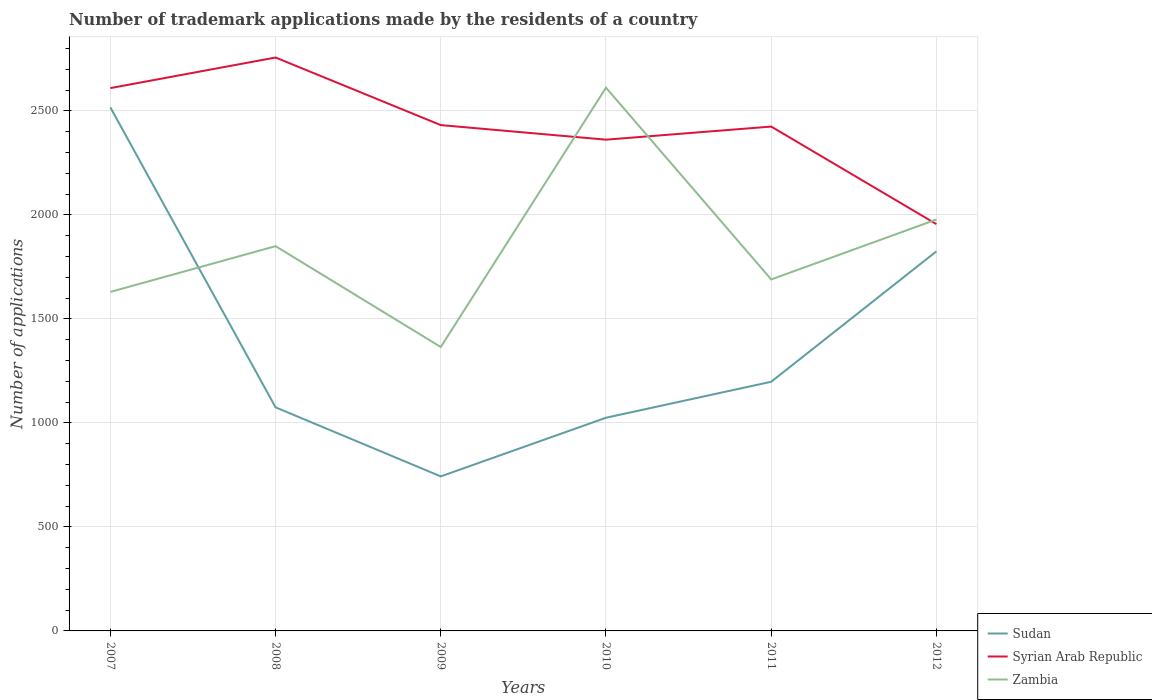How many different coloured lines are there?
Offer a terse response. 3. Is the number of lines equal to the number of legend labels?
Provide a succinct answer. Yes. Across all years, what is the maximum number of trademark applications made by the residents in Sudan?
Provide a succinct answer. 743. What is the total number of trademark applications made by the residents in Syrian Arab Republic in the graph?
Provide a succinct answer. 476. What is the difference between the highest and the second highest number of trademark applications made by the residents in Syrian Arab Republic?
Make the answer very short. 801. What is the difference between the highest and the lowest number of trademark applications made by the residents in Sudan?
Your response must be concise. 2. How many lines are there?
Your response must be concise. 3. How many years are there in the graph?
Ensure brevity in your answer.  6. What is the difference between two consecutive major ticks on the Y-axis?
Give a very brief answer. 500. Does the graph contain grids?
Your answer should be very brief. Yes. Where does the legend appear in the graph?
Your answer should be compact. Bottom right. How many legend labels are there?
Ensure brevity in your answer.  3. What is the title of the graph?
Ensure brevity in your answer.  Number of trademark applications made by the residents of a country. Does "Fragile and conflict affected situations" appear as one of the legend labels in the graph?
Offer a very short reply. No. What is the label or title of the X-axis?
Provide a short and direct response. Years. What is the label or title of the Y-axis?
Give a very brief answer. Number of applications. What is the Number of applications of Sudan in 2007?
Make the answer very short. 2517. What is the Number of applications of Syrian Arab Republic in 2007?
Make the answer very short. 2610. What is the Number of applications of Zambia in 2007?
Give a very brief answer. 1630. What is the Number of applications of Sudan in 2008?
Your answer should be very brief. 1075. What is the Number of applications of Syrian Arab Republic in 2008?
Keep it short and to the point. 2757. What is the Number of applications of Zambia in 2008?
Offer a terse response. 1850. What is the Number of applications of Sudan in 2009?
Offer a terse response. 743. What is the Number of applications of Syrian Arab Republic in 2009?
Provide a succinct answer. 2432. What is the Number of applications in Zambia in 2009?
Your answer should be compact. 1365. What is the Number of applications of Sudan in 2010?
Keep it short and to the point. 1025. What is the Number of applications in Syrian Arab Republic in 2010?
Offer a terse response. 2362. What is the Number of applications in Zambia in 2010?
Make the answer very short. 2612. What is the Number of applications of Sudan in 2011?
Provide a succinct answer. 1198. What is the Number of applications of Syrian Arab Republic in 2011?
Provide a succinct answer. 2425. What is the Number of applications in Zambia in 2011?
Make the answer very short. 1690. What is the Number of applications of Sudan in 2012?
Provide a short and direct response. 1825. What is the Number of applications of Syrian Arab Republic in 2012?
Your answer should be compact. 1956. What is the Number of applications of Zambia in 2012?
Ensure brevity in your answer.  1978. Across all years, what is the maximum Number of applications of Sudan?
Ensure brevity in your answer.  2517. Across all years, what is the maximum Number of applications in Syrian Arab Republic?
Ensure brevity in your answer.  2757. Across all years, what is the maximum Number of applications in Zambia?
Make the answer very short. 2612. Across all years, what is the minimum Number of applications of Sudan?
Provide a succinct answer. 743. Across all years, what is the minimum Number of applications in Syrian Arab Republic?
Your answer should be compact. 1956. Across all years, what is the minimum Number of applications of Zambia?
Your response must be concise. 1365. What is the total Number of applications of Sudan in the graph?
Provide a succinct answer. 8383. What is the total Number of applications in Syrian Arab Republic in the graph?
Your answer should be very brief. 1.45e+04. What is the total Number of applications of Zambia in the graph?
Provide a short and direct response. 1.11e+04. What is the difference between the Number of applications of Sudan in 2007 and that in 2008?
Ensure brevity in your answer.  1442. What is the difference between the Number of applications of Syrian Arab Republic in 2007 and that in 2008?
Make the answer very short. -147. What is the difference between the Number of applications of Zambia in 2007 and that in 2008?
Offer a terse response. -220. What is the difference between the Number of applications in Sudan in 2007 and that in 2009?
Make the answer very short. 1774. What is the difference between the Number of applications in Syrian Arab Republic in 2007 and that in 2009?
Provide a succinct answer. 178. What is the difference between the Number of applications in Zambia in 2007 and that in 2009?
Keep it short and to the point. 265. What is the difference between the Number of applications of Sudan in 2007 and that in 2010?
Provide a succinct answer. 1492. What is the difference between the Number of applications in Syrian Arab Republic in 2007 and that in 2010?
Keep it short and to the point. 248. What is the difference between the Number of applications of Zambia in 2007 and that in 2010?
Your answer should be very brief. -982. What is the difference between the Number of applications in Sudan in 2007 and that in 2011?
Provide a succinct answer. 1319. What is the difference between the Number of applications in Syrian Arab Republic in 2007 and that in 2011?
Your response must be concise. 185. What is the difference between the Number of applications of Zambia in 2007 and that in 2011?
Make the answer very short. -60. What is the difference between the Number of applications in Sudan in 2007 and that in 2012?
Your answer should be very brief. 692. What is the difference between the Number of applications in Syrian Arab Republic in 2007 and that in 2012?
Make the answer very short. 654. What is the difference between the Number of applications of Zambia in 2007 and that in 2012?
Offer a very short reply. -348. What is the difference between the Number of applications of Sudan in 2008 and that in 2009?
Ensure brevity in your answer.  332. What is the difference between the Number of applications of Syrian Arab Republic in 2008 and that in 2009?
Your answer should be very brief. 325. What is the difference between the Number of applications of Zambia in 2008 and that in 2009?
Give a very brief answer. 485. What is the difference between the Number of applications of Syrian Arab Republic in 2008 and that in 2010?
Ensure brevity in your answer.  395. What is the difference between the Number of applications in Zambia in 2008 and that in 2010?
Ensure brevity in your answer.  -762. What is the difference between the Number of applications in Sudan in 2008 and that in 2011?
Offer a terse response. -123. What is the difference between the Number of applications in Syrian Arab Republic in 2008 and that in 2011?
Your answer should be compact. 332. What is the difference between the Number of applications in Zambia in 2008 and that in 2011?
Give a very brief answer. 160. What is the difference between the Number of applications in Sudan in 2008 and that in 2012?
Offer a terse response. -750. What is the difference between the Number of applications in Syrian Arab Republic in 2008 and that in 2012?
Ensure brevity in your answer.  801. What is the difference between the Number of applications in Zambia in 2008 and that in 2012?
Ensure brevity in your answer.  -128. What is the difference between the Number of applications in Sudan in 2009 and that in 2010?
Provide a succinct answer. -282. What is the difference between the Number of applications of Zambia in 2009 and that in 2010?
Make the answer very short. -1247. What is the difference between the Number of applications in Sudan in 2009 and that in 2011?
Give a very brief answer. -455. What is the difference between the Number of applications in Zambia in 2009 and that in 2011?
Offer a very short reply. -325. What is the difference between the Number of applications of Sudan in 2009 and that in 2012?
Provide a succinct answer. -1082. What is the difference between the Number of applications in Syrian Arab Republic in 2009 and that in 2012?
Keep it short and to the point. 476. What is the difference between the Number of applications of Zambia in 2009 and that in 2012?
Your answer should be compact. -613. What is the difference between the Number of applications of Sudan in 2010 and that in 2011?
Provide a short and direct response. -173. What is the difference between the Number of applications of Syrian Arab Republic in 2010 and that in 2011?
Offer a very short reply. -63. What is the difference between the Number of applications in Zambia in 2010 and that in 2011?
Your answer should be compact. 922. What is the difference between the Number of applications in Sudan in 2010 and that in 2012?
Ensure brevity in your answer.  -800. What is the difference between the Number of applications of Syrian Arab Republic in 2010 and that in 2012?
Offer a very short reply. 406. What is the difference between the Number of applications of Zambia in 2010 and that in 2012?
Provide a succinct answer. 634. What is the difference between the Number of applications in Sudan in 2011 and that in 2012?
Your answer should be very brief. -627. What is the difference between the Number of applications of Syrian Arab Republic in 2011 and that in 2012?
Provide a short and direct response. 469. What is the difference between the Number of applications of Zambia in 2011 and that in 2012?
Your response must be concise. -288. What is the difference between the Number of applications of Sudan in 2007 and the Number of applications of Syrian Arab Republic in 2008?
Make the answer very short. -240. What is the difference between the Number of applications in Sudan in 2007 and the Number of applications in Zambia in 2008?
Your answer should be very brief. 667. What is the difference between the Number of applications in Syrian Arab Republic in 2007 and the Number of applications in Zambia in 2008?
Offer a very short reply. 760. What is the difference between the Number of applications of Sudan in 2007 and the Number of applications of Syrian Arab Republic in 2009?
Your answer should be compact. 85. What is the difference between the Number of applications of Sudan in 2007 and the Number of applications of Zambia in 2009?
Your answer should be very brief. 1152. What is the difference between the Number of applications of Syrian Arab Republic in 2007 and the Number of applications of Zambia in 2009?
Your response must be concise. 1245. What is the difference between the Number of applications in Sudan in 2007 and the Number of applications in Syrian Arab Republic in 2010?
Make the answer very short. 155. What is the difference between the Number of applications of Sudan in 2007 and the Number of applications of Zambia in 2010?
Your answer should be compact. -95. What is the difference between the Number of applications in Sudan in 2007 and the Number of applications in Syrian Arab Republic in 2011?
Your answer should be very brief. 92. What is the difference between the Number of applications in Sudan in 2007 and the Number of applications in Zambia in 2011?
Offer a terse response. 827. What is the difference between the Number of applications of Syrian Arab Republic in 2007 and the Number of applications of Zambia in 2011?
Your response must be concise. 920. What is the difference between the Number of applications in Sudan in 2007 and the Number of applications in Syrian Arab Republic in 2012?
Offer a terse response. 561. What is the difference between the Number of applications of Sudan in 2007 and the Number of applications of Zambia in 2012?
Provide a succinct answer. 539. What is the difference between the Number of applications of Syrian Arab Republic in 2007 and the Number of applications of Zambia in 2012?
Provide a succinct answer. 632. What is the difference between the Number of applications of Sudan in 2008 and the Number of applications of Syrian Arab Republic in 2009?
Your response must be concise. -1357. What is the difference between the Number of applications of Sudan in 2008 and the Number of applications of Zambia in 2009?
Provide a succinct answer. -290. What is the difference between the Number of applications of Syrian Arab Republic in 2008 and the Number of applications of Zambia in 2009?
Ensure brevity in your answer.  1392. What is the difference between the Number of applications of Sudan in 2008 and the Number of applications of Syrian Arab Republic in 2010?
Your response must be concise. -1287. What is the difference between the Number of applications of Sudan in 2008 and the Number of applications of Zambia in 2010?
Make the answer very short. -1537. What is the difference between the Number of applications in Syrian Arab Republic in 2008 and the Number of applications in Zambia in 2010?
Offer a terse response. 145. What is the difference between the Number of applications in Sudan in 2008 and the Number of applications in Syrian Arab Republic in 2011?
Provide a short and direct response. -1350. What is the difference between the Number of applications in Sudan in 2008 and the Number of applications in Zambia in 2011?
Offer a terse response. -615. What is the difference between the Number of applications of Syrian Arab Republic in 2008 and the Number of applications of Zambia in 2011?
Your answer should be compact. 1067. What is the difference between the Number of applications in Sudan in 2008 and the Number of applications in Syrian Arab Republic in 2012?
Give a very brief answer. -881. What is the difference between the Number of applications of Sudan in 2008 and the Number of applications of Zambia in 2012?
Offer a terse response. -903. What is the difference between the Number of applications of Syrian Arab Republic in 2008 and the Number of applications of Zambia in 2012?
Keep it short and to the point. 779. What is the difference between the Number of applications of Sudan in 2009 and the Number of applications of Syrian Arab Republic in 2010?
Offer a terse response. -1619. What is the difference between the Number of applications of Sudan in 2009 and the Number of applications of Zambia in 2010?
Give a very brief answer. -1869. What is the difference between the Number of applications in Syrian Arab Republic in 2009 and the Number of applications in Zambia in 2010?
Your answer should be compact. -180. What is the difference between the Number of applications of Sudan in 2009 and the Number of applications of Syrian Arab Republic in 2011?
Ensure brevity in your answer.  -1682. What is the difference between the Number of applications in Sudan in 2009 and the Number of applications in Zambia in 2011?
Offer a very short reply. -947. What is the difference between the Number of applications of Syrian Arab Republic in 2009 and the Number of applications of Zambia in 2011?
Give a very brief answer. 742. What is the difference between the Number of applications in Sudan in 2009 and the Number of applications in Syrian Arab Republic in 2012?
Your answer should be very brief. -1213. What is the difference between the Number of applications of Sudan in 2009 and the Number of applications of Zambia in 2012?
Your answer should be compact. -1235. What is the difference between the Number of applications in Syrian Arab Republic in 2009 and the Number of applications in Zambia in 2012?
Give a very brief answer. 454. What is the difference between the Number of applications in Sudan in 2010 and the Number of applications in Syrian Arab Republic in 2011?
Your answer should be compact. -1400. What is the difference between the Number of applications in Sudan in 2010 and the Number of applications in Zambia in 2011?
Your answer should be compact. -665. What is the difference between the Number of applications in Syrian Arab Republic in 2010 and the Number of applications in Zambia in 2011?
Your response must be concise. 672. What is the difference between the Number of applications of Sudan in 2010 and the Number of applications of Syrian Arab Republic in 2012?
Your response must be concise. -931. What is the difference between the Number of applications in Sudan in 2010 and the Number of applications in Zambia in 2012?
Make the answer very short. -953. What is the difference between the Number of applications in Syrian Arab Republic in 2010 and the Number of applications in Zambia in 2012?
Keep it short and to the point. 384. What is the difference between the Number of applications of Sudan in 2011 and the Number of applications of Syrian Arab Republic in 2012?
Your answer should be compact. -758. What is the difference between the Number of applications in Sudan in 2011 and the Number of applications in Zambia in 2012?
Your response must be concise. -780. What is the difference between the Number of applications in Syrian Arab Republic in 2011 and the Number of applications in Zambia in 2012?
Provide a short and direct response. 447. What is the average Number of applications of Sudan per year?
Your answer should be compact. 1397.17. What is the average Number of applications in Syrian Arab Republic per year?
Provide a short and direct response. 2423.67. What is the average Number of applications of Zambia per year?
Provide a short and direct response. 1854.17. In the year 2007, what is the difference between the Number of applications of Sudan and Number of applications of Syrian Arab Republic?
Your answer should be very brief. -93. In the year 2007, what is the difference between the Number of applications of Sudan and Number of applications of Zambia?
Your answer should be compact. 887. In the year 2007, what is the difference between the Number of applications in Syrian Arab Republic and Number of applications in Zambia?
Provide a succinct answer. 980. In the year 2008, what is the difference between the Number of applications in Sudan and Number of applications in Syrian Arab Republic?
Offer a terse response. -1682. In the year 2008, what is the difference between the Number of applications of Sudan and Number of applications of Zambia?
Ensure brevity in your answer.  -775. In the year 2008, what is the difference between the Number of applications in Syrian Arab Republic and Number of applications in Zambia?
Offer a very short reply. 907. In the year 2009, what is the difference between the Number of applications in Sudan and Number of applications in Syrian Arab Republic?
Provide a short and direct response. -1689. In the year 2009, what is the difference between the Number of applications of Sudan and Number of applications of Zambia?
Your answer should be very brief. -622. In the year 2009, what is the difference between the Number of applications of Syrian Arab Republic and Number of applications of Zambia?
Your answer should be very brief. 1067. In the year 2010, what is the difference between the Number of applications of Sudan and Number of applications of Syrian Arab Republic?
Provide a succinct answer. -1337. In the year 2010, what is the difference between the Number of applications in Sudan and Number of applications in Zambia?
Offer a very short reply. -1587. In the year 2010, what is the difference between the Number of applications in Syrian Arab Republic and Number of applications in Zambia?
Ensure brevity in your answer.  -250. In the year 2011, what is the difference between the Number of applications in Sudan and Number of applications in Syrian Arab Republic?
Provide a succinct answer. -1227. In the year 2011, what is the difference between the Number of applications in Sudan and Number of applications in Zambia?
Offer a terse response. -492. In the year 2011, what is the difference between the Number of applications in Syrian Arab Republic and Number of applications in Zambia?
Your answer should be compact. 735. In the year 2012, what is the difference between the Number of applications of Sudan and Number of applications of Syrian Arab Republic?
Your answer should be very brief. -131. In the year 2012, what is the difference between the Number of applications of Sudan and Number of applications of Zambia?
Provide a succinct answer. -153. In the year 2012, what is the difference between the Number of applications in Syrian Arab Republic and Number of applications in Zambia?
Your answer should be compact. -22. What is the ratio of the Number of applications in Sudan in 2007 to that in 2008?
Your answer should be compact. 2.34. What is the ratio of the Number of applications of Syrian Arab Republic in 2007 to that in 2008?
Keep it short and to the point. 0.95. What is the ratio of the Number of applications in Zambia in 2007 to that in 2008?
Your answer should be compact. 0.88. What is the ratio of the Number of applications of Sudan in 2007 to that in 2009?
Provide a short and direct response. 3.39. What is the ratio of the Number of applications of Syrian Arab Republic in 2007 to that in 2009?
Offer a very short reply. 1.07. What is the ratio of the Number of applications in Zambia in 2007 to that in 2009?
Your response must be concise. 1.19. What is the ratio of the Number of applications of Sudan in 2007 to that in 2010?
Your answer should be very brief. 2.46. What is the ratio of the Number of applications in Syrian Arab Republic in 2007 to that in 2010?
Offer a very short reply. 1.1. What is the ratio of the Number of applications in Zambia in 2007 to that in 2010?
Offer a terse response. 0.62. What is the ratio of the Number of applications in Sudan in 2007 to that in 2011?
Your answer should be very brief. 2.1. What is the ratio of the Number of applications in Syrian Arab Republic in 2007 to that in 2011?
Give a very brief answer. 1.08. What is the ratio of the Number of applications in Zambia in 2007 to that in 2011?
Your response must be concise. 0.96. What is the ratio of the Number of applications in Sudan in 2007 to that in 2012?
Your response must be concise. 1.38. What is the ratio of the Number of applications of Syrian Arab Republic in 2007 to that in 2012?
Ensure brevity in your answer.  1.33. What is the ratio of the Number of applications in Zambia in 2007 to that in 2012?
Provide a short and direct response. 0.82. What is the ratio of the Number of applications of Sudan in 2008 to that in 2009?
Ensure brevity in your answer.  1.45. What is the ratio of the Number of applications of Syrian Arab Republic in 2008 to that in 2009?
Your response must be concise. 1.13. What is the ratio of the Number of applications of Zambia in 2008 to that in 2009?
Provide a succinct answer. 1.36. What is the ratio of the Number of applications of Sudan in 2008 to that in 2010?
Provide a short and direct response. 1.05. What is the ratio of the Number of applications of Syrian Arab Republic in 2008 to that in 2010?
Ensure brevity in your answer.  1.17. What is the ratio of the Number of applications in Zambia in 2008 to that in 2010?
Make the answer very short. 0.71. What is the ratio of the Number of applications in Sudan in 2008 to that in 2011?
Keep it short and to the point. 0.9. What is the ratio of the Number of applications of Syrian Arab Republic in 2008 to that in 2011?
Offer a terse response. 1.14. What is the ratio of the Number of applications in Zambia in 2008 to that in 2011?
Offer a terse response. 1.09. What is the ratio of the Number of applications in Sudan in 2008 to that in 2012?
Give a very brief answer. 0.59. What is the ratio of the Number of applications in Syrian Arab Republic in 2008 to that in 2012?
Make the answer very short. 1.41. What is the ratio of the Number of applications of Zambia in 2008 to that in 2012?
Your answer should be very brief. 0.94. What is the ratio of the Number of applications in Sudan in 2009 to that in 2010?
Ensure brevity in your answer.  0.72. What is the ratio of the Number of applications in Syrian Arab Republic in 2009 to that in 2010?
Provide a short and direct response. 1.03. What is the ratio of the Number of applications of Zambia in 2009 to that in 2010?
Keep it short and to the point. 0.52. What is the ratio of the Number of applications in Sudan in 2009 to that in 2011?
Provide a short and direct response. 0.62. What is the ratio of the Number of applications in Zambia in 2009 to that in 2011?
Your answer should be very brief. 0.81. What is the ratio of the Number of applications in Sudan in 2009 to that in 2012?
Offer a terse response. 0.41. What is the ratio of the Number of applications of Syrian Arab Republic in 2009 to that in 2012?
Make the answer very short. 1.24. What is the ratio of the Number of applications in Zambia in 2009 to that in 2012?
Give a very brief answer. 0.69. What is the ratio of the Number of applications in Sudan in 2010 to that in 2011?
Your answer should be compact. 0.86. What is the ratio of the Number of applications in Syrian Arab Republic in 2010 to that in 2011?
Keep it short and to the point. 0.97. What is the ratio of the Number of applications in Zambia in 2010 to that in 2011?
Ensure brevity in your answer.  1.55. What is the ratio of the Number of applications in Sudan in 2010 to that in 2012?
Offer a very short reply. 0.56. What is the ratio of the Number of applications in Syrian Arab Republic in 2010 to that in 2012?
Provide a succinct answer. 1.21. What is the ratio of the Number of applications in Zambia in 2010 to that in 2012?
Make the answer very short. 1.32. What is the ratio of the Number of applications in Sudan in 2011 to that in 2012?
Give a very brief answer. 0.66. What is the ratio of the Number of applications in Syrian Arab Republic in 2011 to that in 2012?
Provide a succinct answer. 1.24. What is the ratio of the Number of applications in Zambia in 2011 to that in 2012?
Keep it short and to the point. 0.85. What is the difference between the highest and the second highest Number of applications of Sudan?
Provide a succinct answer. 692. What is the difference between the highest and the second highest Number of applications in Syrian Arab Republic?
Your answer should be very brief. 147. What is the difference between the highest and the second highest Number of applications in Zambia?
Provide a succinct answer. 634. What is the difference between the highest and the lowest Number of applications in Sudan?
Make the answer very short. 1774. What is the difference between the highest and the lowest Number of applications of Syrian Arab Republic?
Give a very brief answer. 801. What is the difference between the highest and the lowest Number of applications in Zambia?
Provide a succinct answer. 1247. 